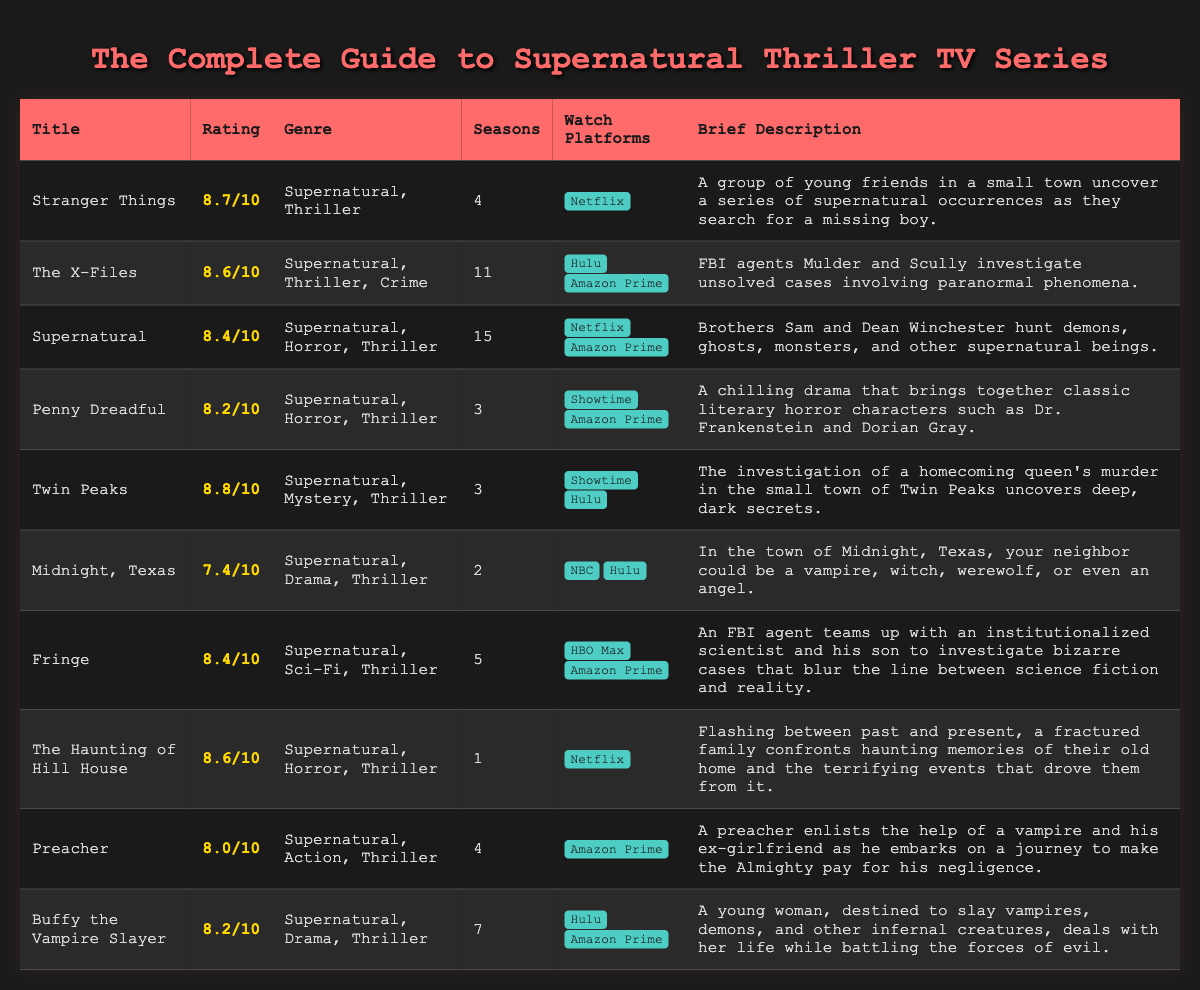What is the rating of Stranger Things? The rating of Stranger Things is explicitly stated in the document as 8.7/10.
Answer: 8.7/10 How many seasons does Supernatural have? The document lists that Supernatural has a total of 15 seasons.
Answer: 15 Which show is classified as both Supernatural and Horror? The document indicates that both Supernatural and The Haunting of Hill House fall under the Supernatural and Horror genres.
Answer: Supernatural What platforms can you watch Twin Peaks on? According to the document, Twin Peaks is available on Showtime and Hulu.
Answer: Showtime, Hulu Which series has the highest rating? The highest rating in the document belongs to Twin Peaks at 8.8/10.
Answer: 8.8/10 What genre is The X-Files categorized under? The genre of The X-Files is explicitly mentioned in the document as Supernatural, Thriller, and Crime.
Answer: Supernatural, Thriller, Crime How many episodes are in Penny Dreadful? Penny Dreadful is listed with 3 seasons, but the total episode count isn't specified in the document. However, the answer can be inferred depending on common episode counts per season.
Answer: 3 Which show features a vampire as a main character in its plot? The document mentions Preacher, where a vampire is a key character.
Answer: Preacher What is the brief description of The Haunting of Hill House? The document provides that it involves a fractured family confronting haunting memories and terrifying events.
Answer: A fractured family confronts haunting memories and terrifying events 